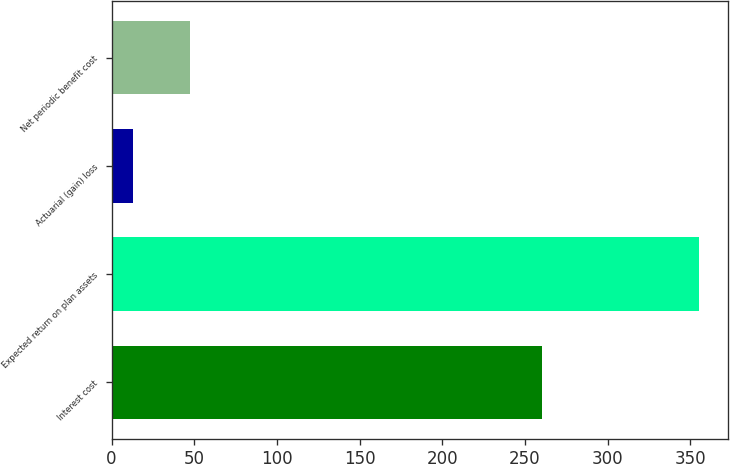Convert chart to OTSL. <chart><loc_0><loc_0><loc_500><loc_500><bar_chart><fcel>Interest cost<fcel>Expected return on plan assets<fcel>Actuarial (gain) loss<fcel>Net periodic benefit cost<nl><fcel>260<fcel>355<fcel>13<fcel>47.2<nl></chart> 